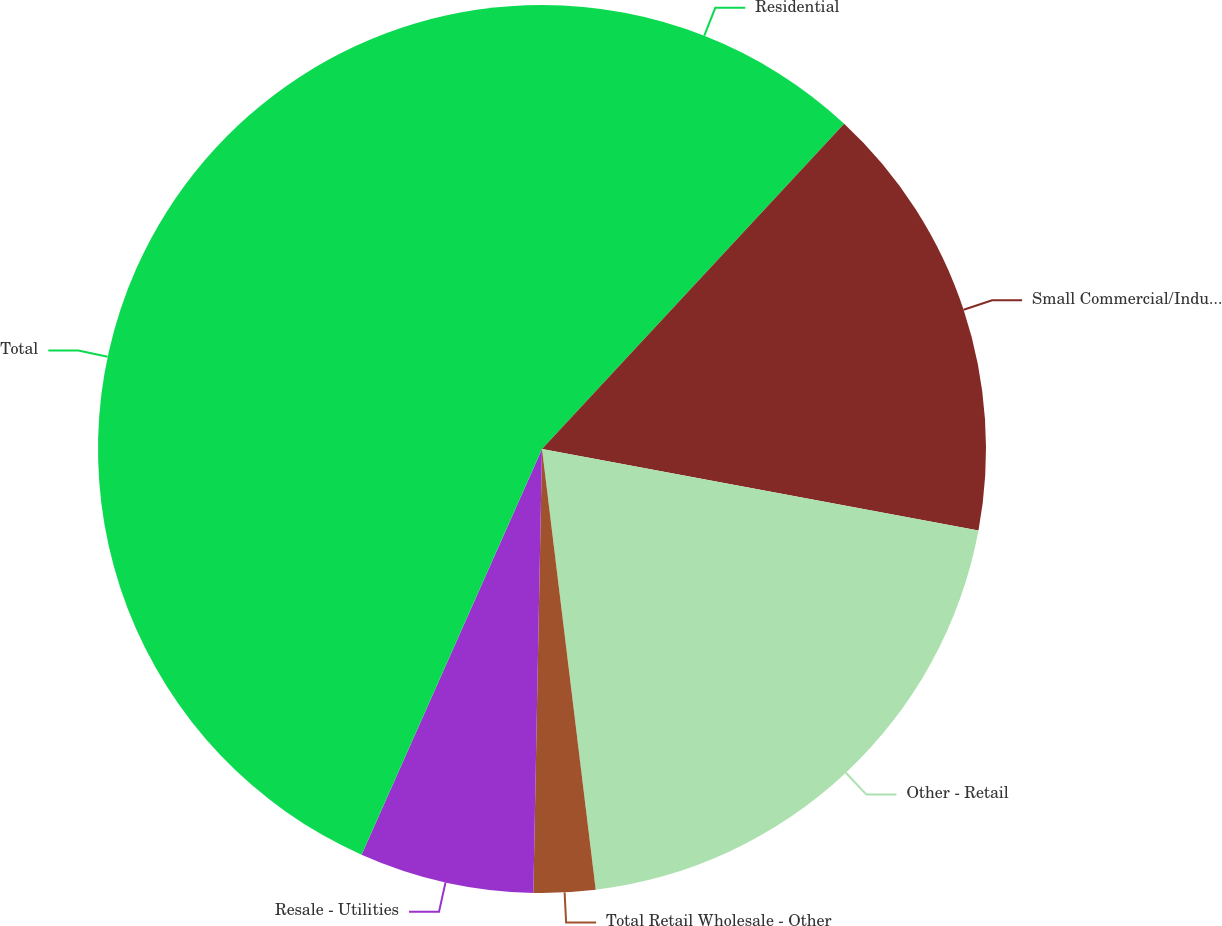Convert chart to OTSL. <chart><loc_0><loc_0><loc_500><loc_500><pie_chart><fcel>Residential<fcel>Small Commercial/Industrial<fcel>Other - Retail<fcel>Total Retail Wholesale - Other<fcel>Resale - Utilities<fcel>Total<nl><fcel>11.91%<fcel>16.02%<fcel>20.13%<fcel>2.24%<fcel>6.35%<fcel>43.33%<nl></chart> 